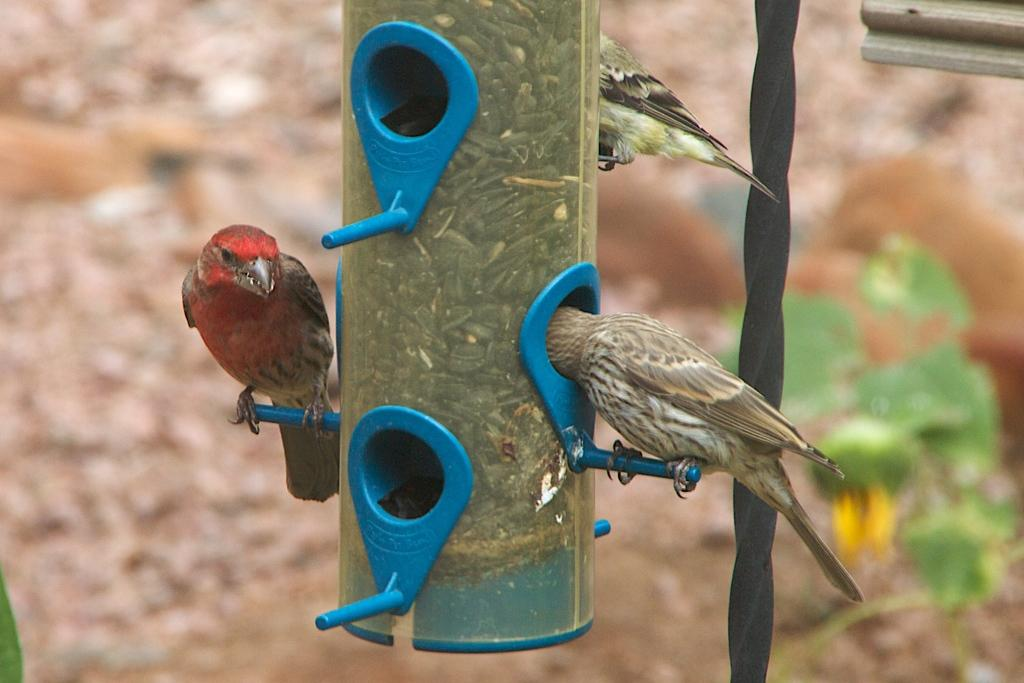What is the main subject in the middle of the image? There is a bird house in the middle of the image. Are there any animals present in the image? Yes, there are birds on the bird house. Can you describe the background of the image? The background of the image is blurred. What type of books can be seen on the bird house in the image? There are no books present on the bird house or in the image. 